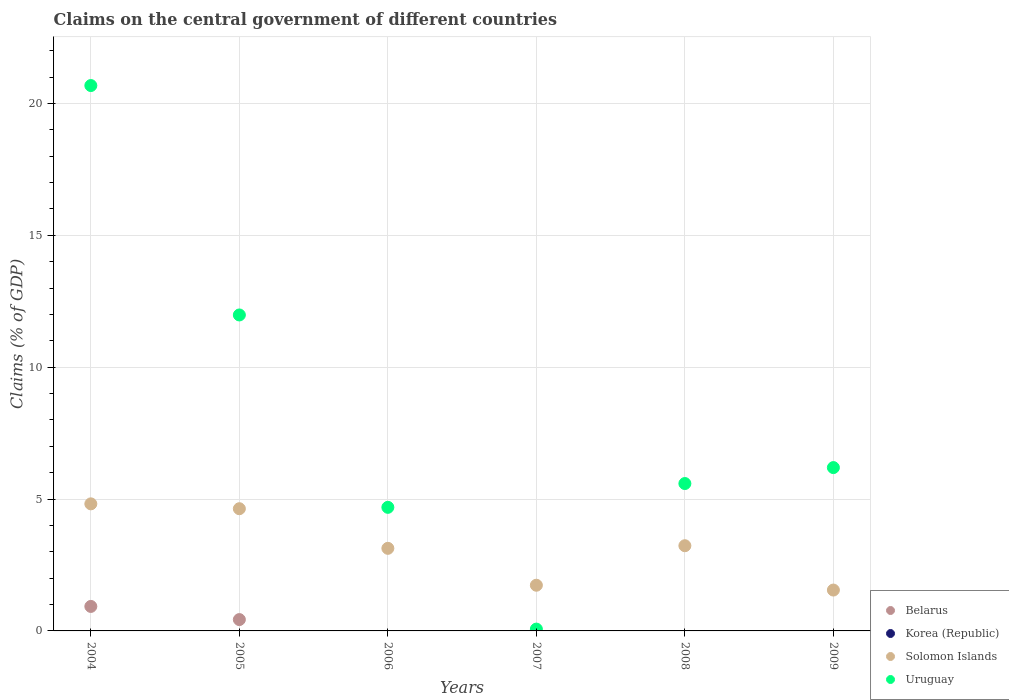How many different coloured dotlines are there?
Make the answer very short. 3. Is the number of dotlines equal to the number of legend labels?
Ensure brevity in your answer.  No. Across all years, what is the maximum percentage of GDP claimed on the central government in Uruguay?
Keep it short and to the point. 20.68. Across all years, what is the minimum percentage of GDP claimed on the central government in Uruguay?
Provide a succinct answer. 0.07. What is the total percentage of GDP claimed on the central government in Uruguay in the graph?
Provide a succinct answer. 49.19. What is the difference between the percentage of GDP claimed on the central government in Uruguay in 2006 and that in 2007?
Your answer should be very brief. 4.62. What is the difference between the percentage of GDP claimed on the central government in Solomon Islands in 2005 and the percentage of GDP claimed on the central government in Uruguay in 2007?
Offer a terse response. 4.56. What is the average percentage of GDP claimed on the central government in Solomon Islands per year?
Provide a succinct answer. 3.18. In the year 2005, what is the difference between the percentage of GDP claimed on the central government in Solomon Islands and percentage of GDP claimed on the central government in Belarus?
Make the answer very short. 4.2. What is the ratio of the percentage of GDP claimed on the central government in Uruguay in 2004 to that in 2006?
Offer a very short reply. 4.41. Is the percentage of GDP claimed on the central government in Solomon Islands in 2004 less than that in 2007?
Your answer should be very brief. No. What is the difference between the highest and the second highest percentage of GDP claimed on the central government in Solomon Islands?
Provide a short and direct response. 0.18. What is the difference between the highest and the lowest percentage of GDP claimed on the central government in Belarus?
Your answer should be very brief. 0.93. Is the sum of the percentage of GDP claimed on the central government in Solomon Islands in 2008 and 2009 greater than the maximum percentage of GDP claimed on the central government in Uruguay across all years?
Give a very brief answer. No. Is it the case that in every year, the sum of the percentage of GDP claimed on the central government in Korea (Republic) and percentage of GDP claimed on the central government in Uruguay  is greater than the sum of percentage of GDP claimed on the central government in Solomon Islands and percentage of GDP claimed on the central government in Belarus?
Provide a succinct answer. No. Does the percentage of GDP claimed on the central government in Korea (Republic) monotonically increase over the years?
Offer a very short reply. No. Is the percentage of GDP claimed on the central government in Korea (Republic) strictly greater than the percentage of GDP claimed on the central government in Uruguay over the years?
Ensure brevity in your answer.  No. Is the percentage of GDP claimed on the central government in Belarus strictly less than the percentage of GDP claimed on the central government in Uruguay over the years?
Your answer should be compact. Yes. How many dotlines are there?
Ensure brevity in your answer.  3. How many years are there in the graph?
Provide a short and direct response. 6. What is the difference between two consecutive major ticks on the Y-axis?
Your answer should be compact. 5. Are the values on the major ticks of Y-axis written in scientific E-notation?
Your answer should be compact. No. Does the graph contain any zero values?
Ensure brevity in your answer.  Yes. Does the graph contain grids?
Offer a very short reply. Yes. Where does the legend appear in the graph?
Provide a succinct answer. Bottom right. What is the title of the graph?
Ensure brevity in your answer.  Claims on the central government of different countries. Does "Panama" appear as one of the legend labels in the graph?
Keep it short and to the point. No. What is the label or title of the X-axis?
Make the answer very short. Years. What is the label or title of the Y-axis?
Make the answer very short. Claims (% of GDP). What is the Claims (% of GDP) of Belarus in 2004?
Your answer should be compact. 0.93. What is the Claims (% of GDP) in Korea (Republic) in 2004?
Your answer should be very brief. 0. What is the Claims (% of GDP) of Solomon Islands in 2004?
Make the answer very short. 4.82. What is the Claims (% of GDP) in Uruguay in 2004?
Your answer should be compact. 20.68. What is the Claims (% of GDP) in Belarus in 2005?
Your answer should be very brief. 0.43. What is the Claims (% of GDP) in Korea (Republic) in 2005?
Provide a short and direct response. 0. What is the Claims (% of GDP) in Solomon Islands in 2005?
Your response must be concise. 4.63. What is the Claims (% of GDP) of Uruguay in 2005?
Provide a short and direct response. 11.98. What is the Claims (% of GDP) in Belarus in 2006?
Offer a terse response. 0. What is the Claims (% of GDP) of Korea (Republic) in 2006?
Offer a terse response. 0. What is the Claims (% of GDP) of Solomon Islands in 2006?
Make the answer very short. 3.13. What is the Claims (% of GDP) of Uruguay in 2006?
Offer a very short reply. 4.69. What is the Claims (% of GDP) in Belarus in 2007?
Give a very brief answer. 0. What is the Claims (% of GDP) of Solomon Islands in 2007?
Provide a succinct answer. 1.73. What is the Claims (% of GDP) of Uruguay in 2007?
Ensure brevity in your answer.  0.07. What is the Claims (% of GDP) of Solomon Islands in 2008?
Offer a terse response. 3.23. What is the Claims (% of GDP) in Uruguay in 2008?
Offer a very short reply. 5.59. What is the Claims (% of GDP) in Solomon Islands in 2009?
Give a very brief answer. 1.55. What is the Claims (% of GDP) of Uruguay in 2009?
Your response must be concise. 6.19. Across all years, what is the maximum Claims (% of GDP) in Belarus?
Offer a terse response. 0.93. Across all years, what is the maximum Claims (% of GDP) in Solomon Islands?
Make the answer very short. 4.82. Across all years, what is the maximum Claims (% of GDP) in Uruguay?
Give a very brief answer. 20.68. Across all years, what is the minimum Claims (% of GDP) of Belarus?
Provide a succinct answer. 0. Across all years, what is the minimum Claims (% of GDP) in Solomon Islands?
Keep it short and to the point. 1.55. Across all years, what is the minimum Claims (% of GDP) of Uruguay?
Provide a short and direct response. 0.07. What is the total Claims (% of GDP) of Belarus in the graph?
Offer a terse response. 1.36. What is the total Claims (% of GDP) in Korea (Republic) in the graph?
Offer a terse response. 0. What is the total Claims (% of GDP) in Solomon Islands in the graph?
Ensure brevity in your answer.  19.09. What is the total Claims (% of GDP) in Uruguay in the graph?
Offer a terse response. 49.19. What is the difference between the Claims (% of GDP) in Belarus in 2004 and that in 2005?
Make the answer very short. 0.5. What is the difference between the Claims (% of GDP) of Solomon Islands in 2004 and that in 2005?
Ensure brevity in your answer.  0.18. What is the difference between the Claims (% of GDP) in Uruguay in 2004 and that in 2005?
Offer a very short reply. 8.7. What is the difference between the Claims (% of GDP) of Solomon Islands in 2004 and that in 2006?
Provide a succinct answer. 1.69. What is the difference between the Claims (% of GDP) of Uruguay in 2004 and that in 2006?
Offer a terse response. 15.99. What is the difference between the Claims (% of GDP) of Solomon Islands in 2004 and that in 2007?
Keep it short and to the point. 3.09. What is the difference between the Claims (% of GDP) in Uruguay in 2004 and that in 2007?
Your answer should be compact. 20.61. What is the difference between the Claims (% of GDP) in Solomon Islands in 2004 and that in 2008?
Your response must be concise. 1.59. What is the difference between the Claims (% of GDP) in Uruguay in 2004 and that in 2008?
Offer a very short reply. 15.09. What is the difference between the Claims (% of GDP) of Solomon Islands in 2004 and that in 2009?
Offer a terse response. 3.27. What is the difference between the Claims (% of GDP) in Uruguay in 2004 and that in 2009?
Give a very brief answer. 14.48. What is the difference between the Claims (% of GDP) of Solomon Islands in 2005 and that in 2006?
Your answer should be very brief. 1.5. What is the difference between the Claims (% of GDP) of Uruguay in 2005 and that in 2006?
Make the answer very short. 7.29. What is the difference between the Claims (% of GDP) of Solomon Islands in 2005 and that in 2007?
Keep it short and to the point. 2.9. What is the difference between the Claims (% of GDP) in Uruguay in 2005 and that in 2007?
Your answer should be compact. 11.91. What is the difference between the Claims (% of GDP) in Solomon Islands in 2005 and that in 2008?
Keep it short and to the point. 1.4. What is the difference between the Claims (% of GDP) of Uruguay in 2005 and that in 2008?
Make the answer very short. 6.39. What is the difference between the Claims (% of GDP) in Solomon Islands in 2005 and that in 2009?
Your answer should be very brief. 3.08. What is the difference between the Claims (% of GDP) of Uruguay in 2005 and that in 2009?
Make the answer very short. 5.79. What is the difference between the Claims (% of GDP) of Solomon Islands in 2006 and that in 2007?
Make the answer very short. 1.4. What is the difference between the Claims (% of GDP) of Uruguay in 2006 and that in 2007?
Make the answer very short. 4.62. What is the difference between the Claims (% of GDP) of Solomon Islands in 2006 and that in 2008?
Make the answer very short. -0.1. What is the difference between the Claims (% of GDP) of Uruguay in 2006 and that in 2008?
Give a very brief answer. -0.9. What is the difference between the Claims (% of GDP) of Solomon Islands in 2006 and that in 2009?
Make the answer very short. 1.58. What is the difference between the Claims (% of GDP) in Uruguay in 2006 and that in 2009?
Offer a terse response. -1.51. What is the difference between the Claims (% of GDP) of Solomon Islands in 2007 and that in 2008?
Make the answer very short. -1.5. What is the difference between the Claims (% of GDP) in Uruguay in 2007 and that in 2008?
Ensure brevity in your answer.  -5.52. What is the difference between the Claims (% of GDP) in Solomon Islands in 2007 and that in 2009?
Keep it short and to the point. 0.18. What is the difference between the Claims (% of GDP) of Uruguay in 2007 and that in 2009?
Your answer should be compact. -6.12. What is the difference between the Claims (% of GDP) in Solomon Islands in 2008 and that in 2009?
Your response must be concise. 1.68. What is the difference between the Claims (% of GDP) in Uruguay in 2008 and that in 2009?
Provide a short and direct response. -0.6. What is the difference between the Claims (% of GDP) in Belarus in 2004 and the Claims (% of GDP) in Solomon Islands in 2005?
Offer a very short reply. -3.7. What is the difference between the Claims (% of GDP) of Belarus in 2004 and the Claims (% of GDP) of Uruguay in 2005?
Your answer should be very brief. -11.05. What is the difference between the Claims (% of GDP) of Solomon Islands in 2004 and the Claims (% of GDP) of Uruguay in 2005?
Your response must be concise. -7.16. What is the difference between the Claims (% of GDP) in Belarus in 2004 and the Claims (% of GDP) in Solomon Islands in 2006?
Offer a very short reply. -2.2. What is the difference between the Claims (% of GDP) of Belarus in 2004 and the Claims (% of GDP) of Uruguay in 2006?
Your response must be concise. -3.76. What is the difference between the Claims (% of GDP) of Solomon Islands in 2004 and the Claims (% of GDP) of Uruguay in 2006?
Your response must be concise. 0.13. What is the difference between the Claims (% of GDP) in Belarus in 2004 and the Claims (% of GDP) in Solomon Islands in 2007?
Your answer should be compact. -0.8. What is the difference between the Claims (% of GDP) in Belarus in 2004 and the Claims (% of GDP) in Uruguay in 2007?
Offer a very short reply. 0.86. What is the difference between the Claims (% of GDP) in Solomon Islands in 2004 and the Claims (% of GDP) in Uruguay in 2007?
Keep it short and to the point. 4.75. What is the difference between the Claims (% of GDP) of Belarus in 2004 and the Claims (% of GDP) of Solomon Islands in 2008?
Give a very brief answer. -2.3. What is the difference between the Claims (% of GDP) of Belarus in 2004 and the Claims (% of GDP) of Uruguay in 2008?
Offer a terse response. -4.66. What is the difference between the Claims (% of GDP) of Solomon Islands in 2004 and the Claims (% of GDP) of Uruguay in 2008?
Provide a short and direct response. -0.77. What is the difference between the Claims (% of GDP) of Belarus in 2004 and the Claims (% of GDP) of Solomon Islands in 2009?
Provide a short and direct response. -0.62. What is the difference between the Claims (% of GDP) of Belarus in 2004 and the Claims (% of GDP) of Uruguay in 2009?
Your answer should be very brief. -5.26. What is the difference between the Claims (% of GDP) of Solomon Islands in 2004 and the Claims (% of GDP) of Uruguay in 2009?
Give a very brief answer. -1.37. What is the difference between the Claims (% of GDP) in Belarus in 2005 and the Claims (% of GDP) in Solomon Islands in 2006?
Keep it short and to the point. -2.7. What is the difference between the Claims (% of GDP) of Belarus in 2005 and the Claims (% of GDP) of Uruguay in 2006?
Provide a short and direct response. -4.26. What is the difference between the Claims (% of GDP) of Solomon Islands in 2005 and the Claims (% of GDP) of Uruguay in 2006?
Your answer should be compact. -0.05. What is the difference between the Claims (% of GDP) of Belarus in 2005 and the Claims (% of GDP) of Solomon Islands in 2007?
Offer a terse response. -1.3. What is the difference between the Claims (% of GDP) in Belarus in 2005 and the Claims (% of GDP) in Uruguay in 2007?
Provide a short and direct response. 0.36. What is the difference between the Claims (% of GDP) of Solomon Islands in 2005 and the Claims (% of GDP) of Uruguay in 2007?
Keep it short and to the point. 4.56. What is the difference between the Claims (% of GDP) of Belarus in 2005 and the Claims (% of GDP) of Solomon Islands in 2008?
Your answer should be compact. -2.8. What is the difference between the Claims (% of GDP) in Belarus in 2005 and the Claims (% of GDP) in Uruguay in 2008?
Offer a terse response. -5.16. What is the difference between the Claims (% of GDP) in Solomon Islands in 2005 and the Claims (% of GDP) in Uruguay in 2008?
Your answer should be very brief. -0.95. What is the difference between the Claims (% of GDP) in Belarus in 2005 and the Claims (% of GDP) in Solomon Islands in 2009?
Offer a very short reply. -1.12. What is the difference between the Claims (% of GDP) in Belarus in 2005 and the Claims (% of GDP) in Uruguay in 2009?
Your response must be concise. -5.76. What is the difference between the Claims (% of GDP) in Solomon Islands in 2005 and the Claims (% of GDP) in Uruguay in 2009?
Make the answer very short. -1.56. What is the difference between the Claims (% of GDP) in Solomon Islands in 2006 and the Claims (% of GDP) in Uruguay in 2007?
Offer a terse response. 3.06. What is the difference between the Claims (% of GDP) of Solomon Islands in 2006 and the Claims (% of GDP) of Uruguay in 2008?
Offer a terse response. -2.46. What is the difference between the Claims (% of GDP) in Solomon Islands in 2006 and the Claims (% of GDP) in Uruguay in 2009?
Offer a terse response. -3.06. What is the difference between the Claims (% of GDP) in Solomon Islands in 2007 and the Claims (% of GDP) in Uruguay in 2008?
Ensure brevity in your answer.  -3.86. What is the difference between the Claims (% of GDP) of Solomon Islands in 2007 and the Claims (% of GDP) of Uruguay in 2009?
Your answer should be compact. -4.46. What is the difference between the Claims (% of GDP) in Solomon Islands in 2008 and the Claims (% of GDP) in Uruguay in 2009?
Your answer should be compact. -2.96. What is the average Claims (% of GDP) in Belarus per year?
Give a very brief answer. 0.23. What is the average Claims (% of GDP) in Korea (Republic) per year?
Your response must be concise. 0. What is the average Claims (% of GDP) in Solomon Islands per year?
Give a very brief answer. 3.18. What is the average Claims (% of GDP) in Uruguay per year?
Make the answer very short. 8.2. In the year 2004, what is the difference between the Claims (% of GDP) in Belarus and Claims (% of GDP) in Solomon Islands?
Your answer should be very brief. -3.89. In the year 2004, what is the difference between the Claims (% of GDP) in Belarus and Claims (% of GDP) in Uruguay?
Ensure brevity in your answer.  -19.75. In the year 2004, what is the difference between the Claims (% of GDP) in Solomon Islands and Claims (% of GDP) in Uruguay?
Keep it short and to the point. -15.86. In the year 2005, what is the difference between the Claims (% of GDP) of Belarus and Claims (% of GDP) of Solomon Islands?
Give a very brief answer. -4.2. In the year 2005, what is the difference between the Claims (% of GDP) in Belarus and Claims (% of GDP) in Uruguay?
Make the answer very short. -11.55. In the year 2005, what is the difference between the Claims (% of GDP) of Solomon Islands and Claims (% of GDP) of Uruguay?
Give a very brief answer. -7.35. In the year 2006, what is the difference between the Claims (% of GDP) in Solomon Islands and Claims (% of GDP) in Uruguay?
Provide a short and direct response. -1.55. In the year 2007, what is the difference between the Claims (% of GDP) of Solomon Islands and Claims (% of GDP) of Uruguay?
Keep it short and to the point. 1.66. In the year 2008, what is the difference between the Claims (% of GDP) of Solomon Islands and Claims (% of GDP) of Uruguay?
Make the answer very short. -2.36. In the year 2009, what is the difference between the Claims (% of GDP) in Solomon Islands and Claims (% of GDP) in Uruguay?
Offer a terse response. -4.64. What is the ratio of the Claims (% of GDP) in Belarus in 2004 to that in 2005?
Offer a terse response. 2.16. What is the ratio of the Claims (% of GDP) of Solomon Islands in 2004 to that in 2005?
Keep it short and to the point. 1.04. What is the ratio of the Claims (% of GDP) of Uruguay in 2004 to that in 2005?
Provide a succinct answer. 1.73. What is the ratio of the Claims (% of GDP) in Solomon Islands in 2004 to that in 2006?
Your answer should be very brief. 1.54. What is the ratio of the Claims (% of GDP) in Uruguay in 2004 to that in 2006?
Provide a short and direct response. 4.41. What is the ratio of the Claims (% of GDP) of Solomon Islands in 2004 to that in 2007?
Give a very brief answer. 2.78. What is the ratio of the Claims (% of GDP) of Uruguay in 2004 to that in 2007?
Give a very brief answer. 298.81. What is the ratio of the Claims (% of GDP) of Solomon Islands in 2004 to that in 2008?
Ensure brevity in your answer.  1.49. What is the ratio of the Claims (% of GDP) in Uruguay in 2004 to that in 2008?
Provide a succinct answer. 3.7. What is the ratio of the Claims (% of GDP) of Solomon Islands in 2004 to that in 2009?
Give a very brief answer. 3.11. What is the ratio of the Claims (% of GDP) in Uruguay in 2004 to that in 2009?
Your response must be concise. 3.34. What is the ratio of the Claims (% of GDP) of Solomon Islands in 2005 to that in 2006?
Provide a succinct answer. 1.48. What is the ratio of the Claims (% of GDP) of Uruguay in 2005 to that in 2006?
Make the answer very short. 2.56. What is the ratio of the Claims (% of GDP) of Solomon Islands in 2005 to that in 2007?
Offer a terse response. 2.67. What is the ratio of the Claims (% of GDP) in Uruguay in 2005 to that in 2007?
Provide a short and direct response. 173.11. What is the ratio of the Claims (% of GDP) in Solomon Islands in 2005 to that in 2008?
Your answer should be compact. 1.43. What is the ratio of the Claims (% of GDP) in Uruguay in 2005 to that in 2008?
Make the answer very short. 2.14. What is the ratio of the Claims (% of GDP) of Solomon Islands in 2005 to that in 2009?
Offer a terse response. 2.99. What is the ratio of the Claims (% of GDP) of Uruguay in 2005 to that in 2009?
Provide a short and direct response. 1.93. What is the ratio of the Claims (% of GDP) of Solomon Islands in 2006 to that in 2007?
Offer a very short reply. 1.81. What is the ratio of the Claims (% of GDP) in Uruguay in 2006 to that in 2007?
Your answer should be compact. 67.71. What is the ratio of the Claims (% of GDP) in Solomon Islands in 2006 to that in 2008?
Offer a terse response. 0.97. What is the ratio of the Claims (% of GDP) of Uruguay in 2006 to that in 2008?
Your answer should be very brief. 0.84. What is the ratio of the Claims (% of GDP) of Solomon Islands in 2006 to that in 2009?
Provide a succinct answer. 2.02. What is the ratio of the Claims (% of GDP) in Uruguay in 2006 to that in 2009?
Provide a short and direct response. 0.76. What is the ratio of the Claims (% of GDP) in Solomon Islands in 2007 to that in 2008?
Your response must be concise. 0.54. What is the ratio of the Claims (% of GDP) in Uruguay in 2007 to that in 2008?
Offer a very short reply. 0.01. What is the ratio of the Claims (% of GDP) in Solomon Islands in 2007 to that in 2009?
Offer a terse response. 1.12. What is the ratio of the Claims (% of GDP) of Uruguay in 2007 to that in 2009?
Provide a short and direct response. 0.01. What is the ratio of the Claims (% of GDP) of Solomon Islands in 2008 to that in 2009?
Your answer should be compact. 2.08. What is the ratio of the Claims (% of GDP) in Uruguay in 2008 to that in 2009?
Offer a terse response. 0.9. What is the difference between the highest and the second highest Claims (% of GDP) in Solomon Islands?
Your answer should be very brief. 0.18. What is the difference between the highest and the second highest Claims (% of GDP) in Uruguay?
Make the answer very short. 8.7. What is the difference between the highest and the lowest Claims (% of GDP) of Belarus?
Give a very brief answer. 0.93. What is the difference between the highest and the lowest Claims (% of GDP) of Solomon Islands?
Provide a succinct answer. 3.27. What is the difference between the highest and the lowest Claims (% of GDP) of Uruguay?
Make the answer very short. 20.61. 